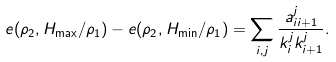<formula> <loc_0><loc_0><loc_500><loc_500>e ( \rho _ { 2 } , H _ { \max } / \rho _ { 1 } ) - e ( \rho _ { 2 } , H _ { \min } / \rho _ { 1 } ) = \sum _ { i , j } \frac { a _ { i i + 1 } ^ { j } } { k _ { i } ^ { j } k _ { i + 1 } ^ { j } } .</formula> 